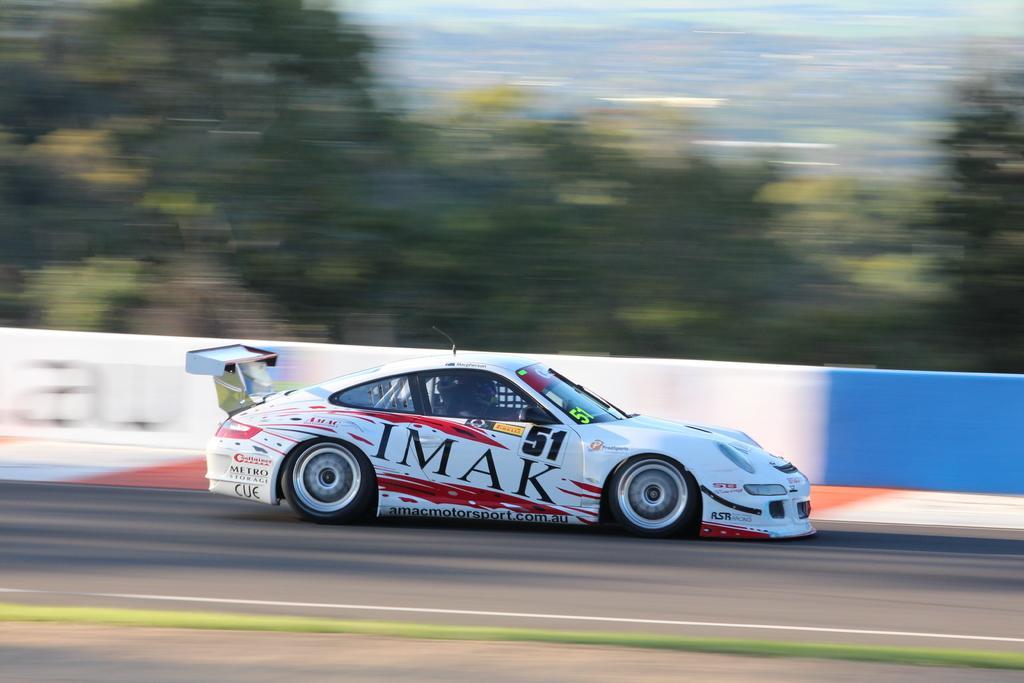How would you summarize this image in a sentence or two? In this image there is a white color car on the road as we can see on the bottom of this image. There is a wall in middle of this image and there are some trees on the top of this image. 